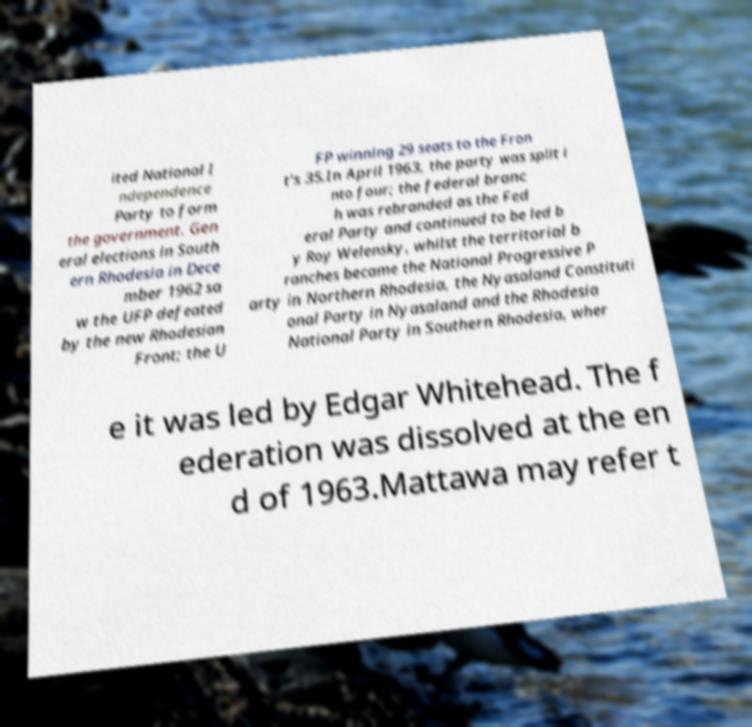Could you assist in decoding the text presented in this image and type it out clearly? ited National I ndependence Party to form the government. Gen eral elections in South ern Rhodesia in Dece mber 1962 sa w the UFP defeated by the new Rhodesian Front; the U FP winning 29 seats to the Fron t's 35.In April 1963, the party was split i nto four; the federal branc h was rebranded as the Fed eral Party and continued to be led b y Roy Welensky, whilst the territorial b ranches became the National Progressive P arty in Northern Rhodesia, the Nyasaland Constituti onal Party in Nyasaland and the Rhodesia National Party in Southern Rhodesia, wher e it was led by Edgar Whitehead. The f ederation was dissolved at the en d of 1963.Mattawa may refer t 